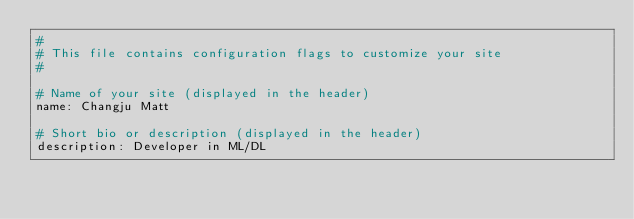Convert code to text. <code><loc_0><loc_0><loc_500><loc_500><_YAML_>#
# This file contains configuration flags to customize your site
#

# Name of your site (displayed in the header)
name: Changju Matt

# Short bio or description (displayed in the header)
description: Developer in ML/DL
</code> 